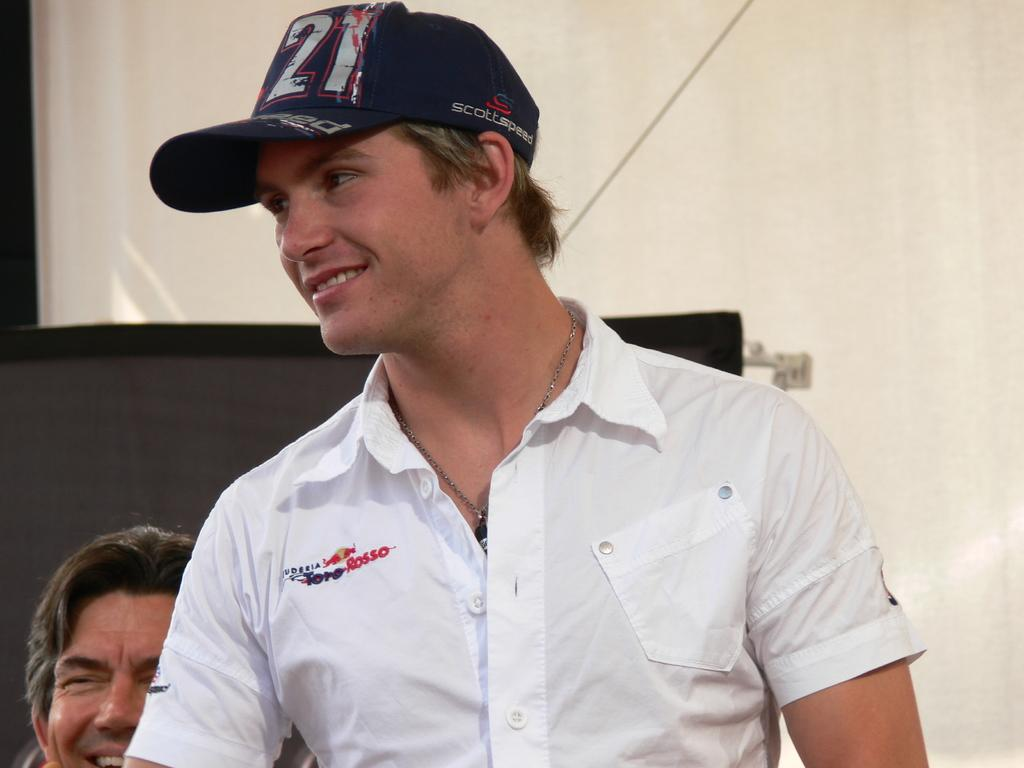Provide a one-sentence caption for the provided image. smiling guy wearing cap with 21 on it ans shirt with toro rosso logo. 